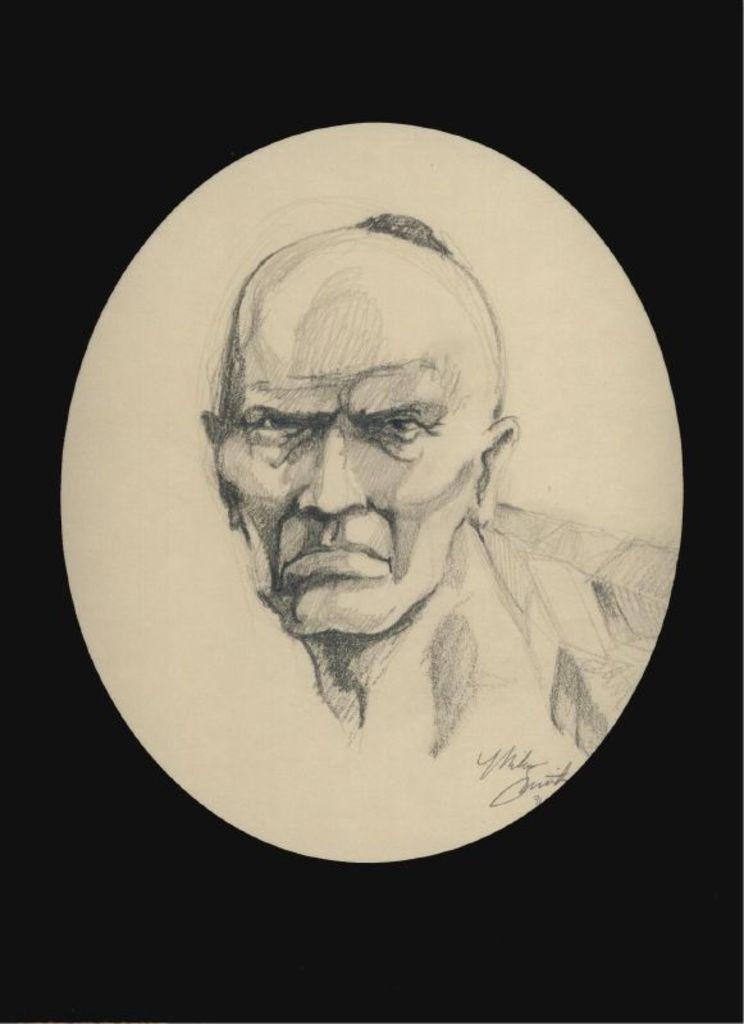What is featured in the image? There is a poster in the image. What type of art is depicted on the poster? The poster contains a man's art. Are there any words on the poster? Yes, there is text on the poster. What type of receipt can be seen in the image? There is no receipt present in the image; it features a poster with a man's art and text. 